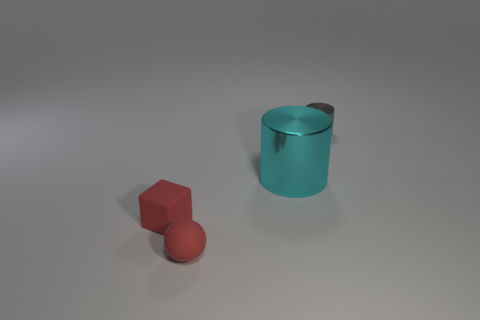Add 1 large cylinders. How many objects exist? 5 Subtract all blocks. How many objects are left? 3 Add 2 red blocks. How many red blocks are left? 3 Add 1 red matte cubes. How many red matte cubes exist? 2 Subtract 1 red cubes. How many objects are left? 3 Subtract all big metal objects. Subtract all red things. How many objects are left? 1 